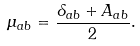Convert formula to latex. <formula><loc_0><loc_0><loc_500><loc_500>\mu _ { a b } = \frac { \delta _ { a b } + A _ { a b } } { 2 } .</formula> 